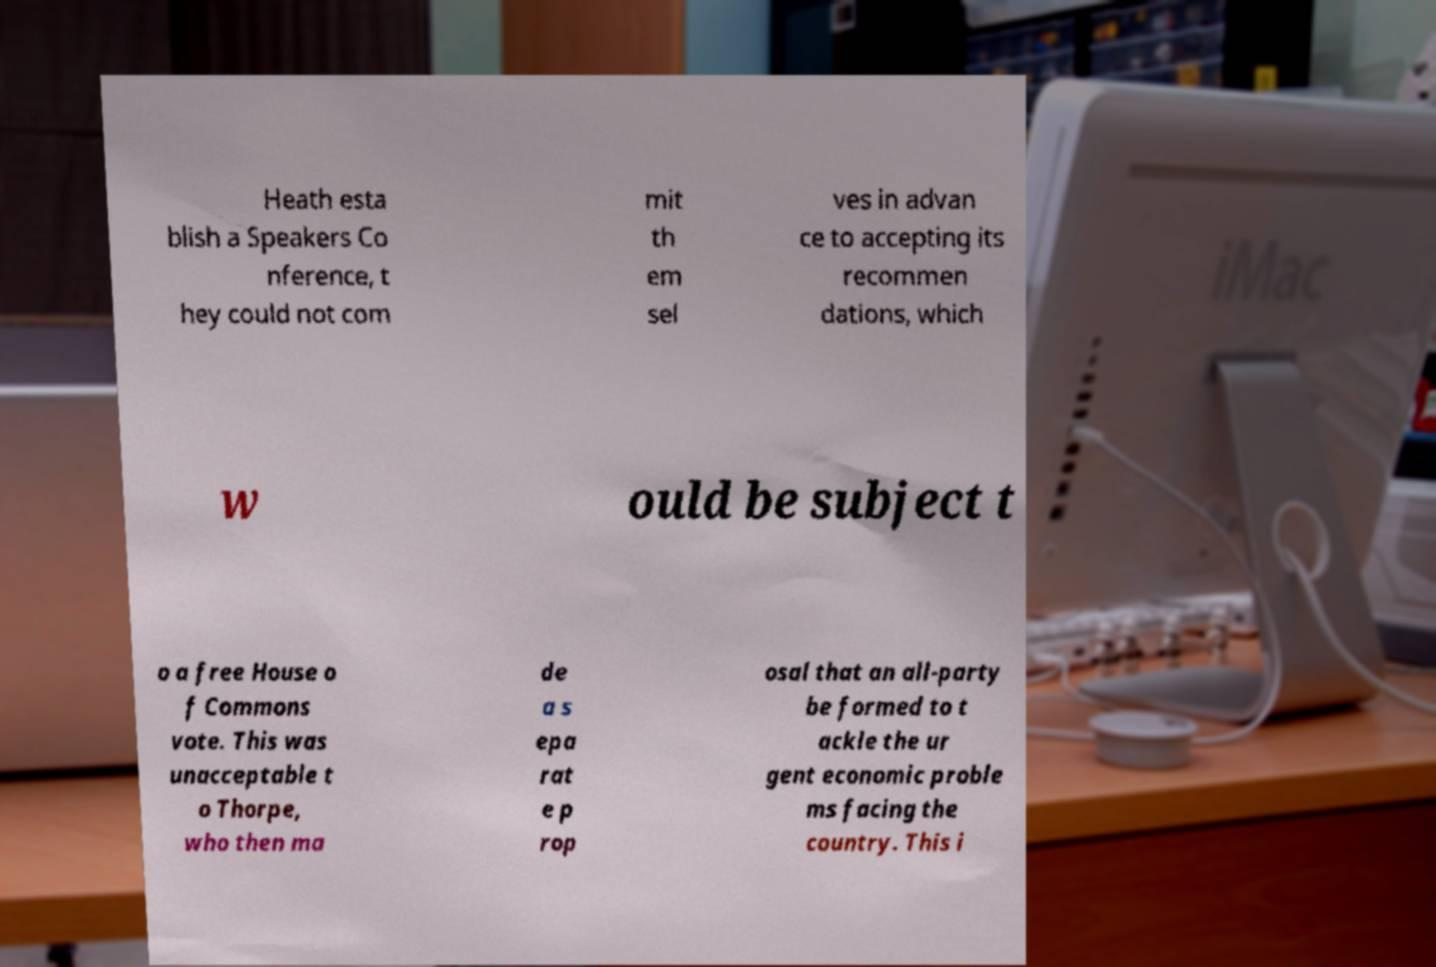What messages or text are displayed in this image? I need them in a readable, typed format. Heath esta blish a Speakers Co nference, t hey could not com mit th em sel ves in advan ce to accepting its recommen dations, which w ould be subject t o a free House o f Commons vote. This was unacceptable t o Thorpe, who then ma de a s epa rat e p rop osal that an all-party be formed to t ackle the ur gent economic proble ms facing the country. This i 